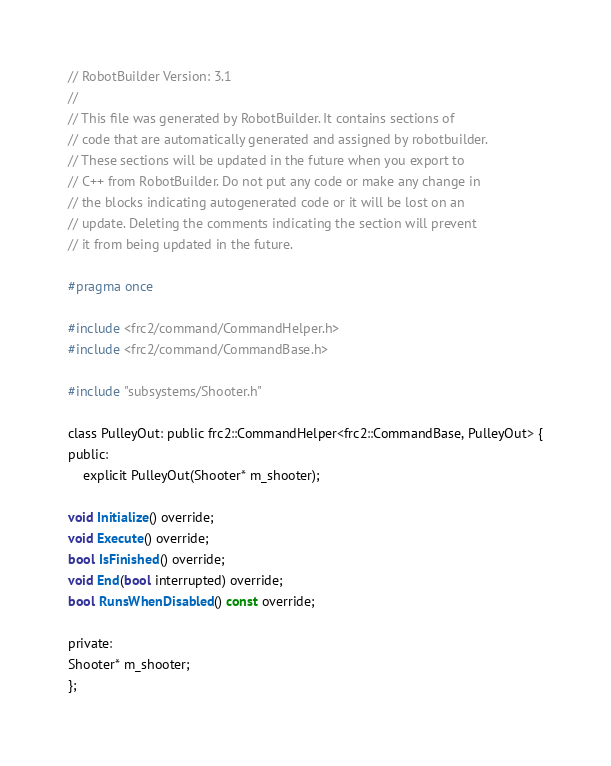Convert code to text. <code><loc_0><loc_0><loc_500><loc_500><_C_>// RobotBuilder Version: 3.1
//
// This file was generated by RobotBuilder. It contains sections of
// code that are automatically generated and assigned by robotbuilder.
// These sections will be updated in the future when you export to
// C++ from RobotBuilder. Do not put any code or make any change in
// the blocks indicating autogenerated code or it will be lost on an
// update. Deleting the comments indicating the section will prevent
// it from being updated in the future.

#pragma once

#include <frc2/command/CommandHelper.h>
#include <frc2/command/CommandBase.h>

#include "subsystems/Shooter.h"

class PulleyOut: public frc2::CommandHelper<frc2::CommandBase, PulleyOut> {
public:
    explicit PulleyOut(Shooter* m_shooter);

void Initialize() override;
void Execute() override;
bool IsFinished() override;
void End(bool interrupted) override;
bool RunsWhenDisabled() const override;

private:
Shooter* m_shooter;
};
</code> 